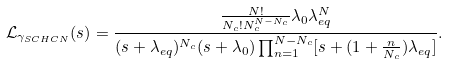Convert formula to latex. <formula><loc_0><loc_0><loc_500><loc_500>\mathcal { L } _ { \gamma _ { S C H C N } } ( s ) & = \frac { \frac { N ! } { N _ { c } ! N _ { c } ^ { N - N _ { c } } } \lambda _ { 0 } \lambda _ { e q } ^ { N } } { ( s + \lambda _ { e q } ) ^ { N _ { c } } ( s + \lambda _ { 0 } ) \prod _ { n = 1 } ^ { N - N _ { c } } [ s + ( 1 + \frac { n } { N _ { c } } ) \lambda _ { e q } ] } .</formula> 